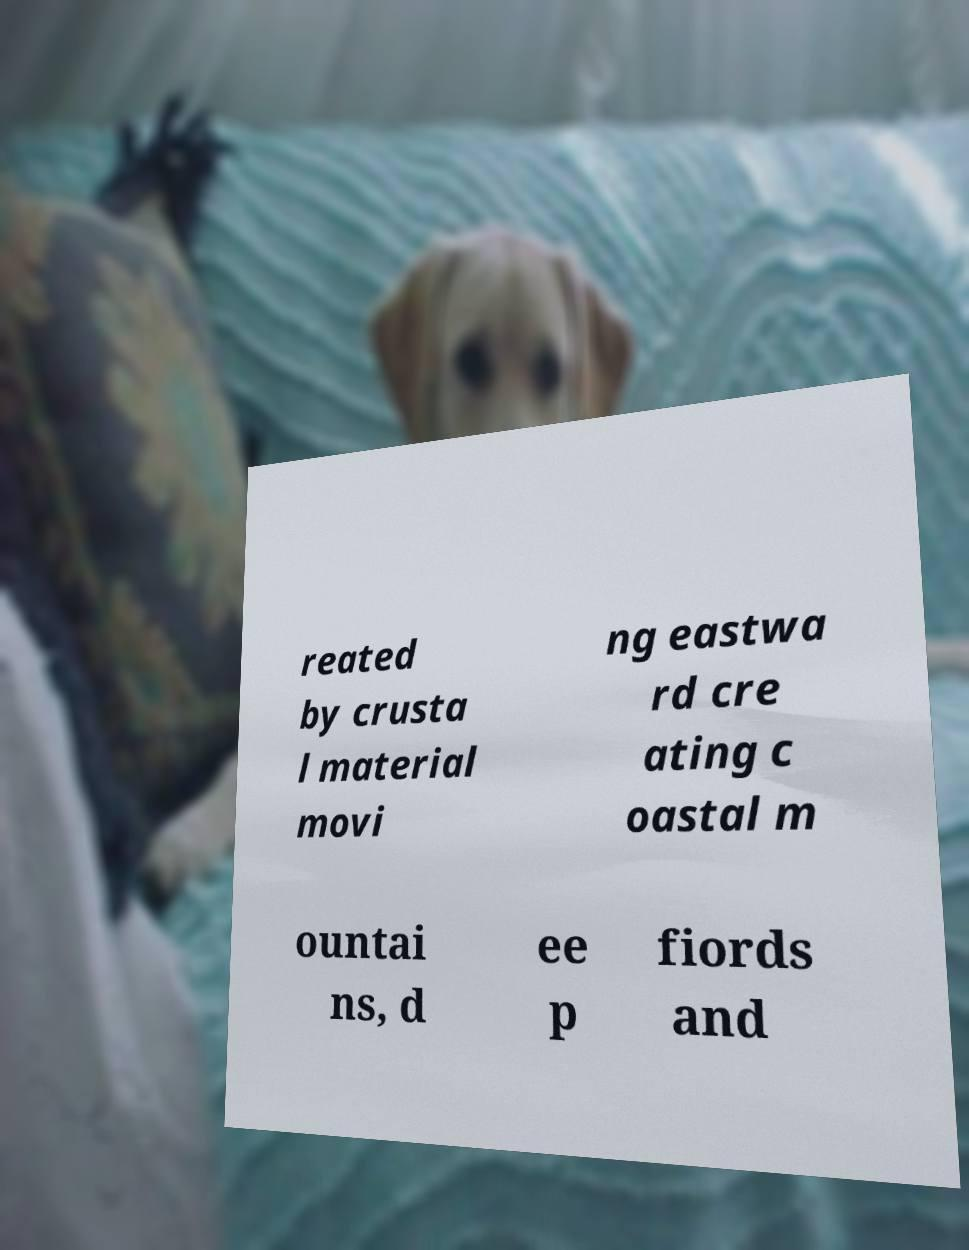Could you extract and type out the text from this image? reated by crusta l material movi ng eastwa rd cre ating c oastal m ountai ns, d ee p fiords and 